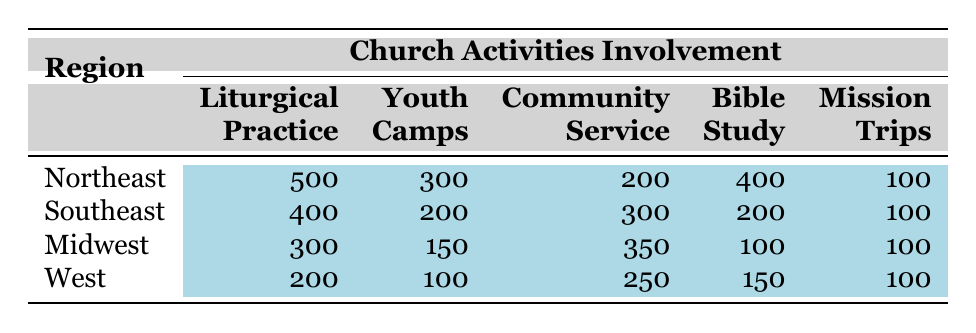What is the total number of Orthodox Christian youth involved in church activities in the Northeast region? The table shows that the total number of youth in the Northeast region is listed as 1500.
Answer: 1500 Which church activity had the highest involvement in the Midwest region? Looking at the Midwest row, the activities listed are Liturgical Practice (300), Youth Camps (150), Community Service (350), Bible Study (100), and Mission Trips (100). The highest number is for Community Service with 350.
Answer: Community Service How many youth participated in Bible Study across all regions? To find the total for Bible Study, we need to add the values from each region: Northeast (400) + Southeast (200) + Midwest (100) + West (150) = 850.
Answer: 850 Is the involvement in Youth Camps in the Southeast region greater than that in the West region? The Southeast has 200 participants in Youth Camps, while the West has 100. Since 200 is greater than 100, the statement is true.
Answer: Yes What is the average number of participants in Liturgical Practice across all regions? To find the average, we add the Liturgical Practice numbers: Northeast (500) + Southeast (400) + Midwest (300) + West (200) = 1400. Dividing by the number of regions (4), we get an average of 1400 / 4 = 350.
Answer: 350 Which region has the least total involvement in church activities? For total involvement, we add all activity participation for each region: Northeast (500+300+200+400+100=1500), Southeast (400+200+300+200+100=1200), Midwest (300+150+350+100+100=1000), West (200+100+250+150+100=800). The smallest total is 800 in the West.
Answer: West Are there more total participants in Mission Trips than in Youth Camps for the entire dataset? The total for Youth Camps is calculated as Northeast (300) + Southeast (200) + Midwest (150) + West (100) = 750. The total for Mission Trips is Northeast (100) + Southeast (100) + Midwest (100) + West (100) = 400. Since 750 is more than 400, it is true that there are more.
Answer: Yes What percentage of total youth in the Northeast were involved in Community Service? The number of youth involved in Community Service in the Northeast is 200. To get the percentage, divide by the total number of youth (1500) and multiply by 100: (200 / 1500) * 100 = 13.33%.
Answer: 13.33% 